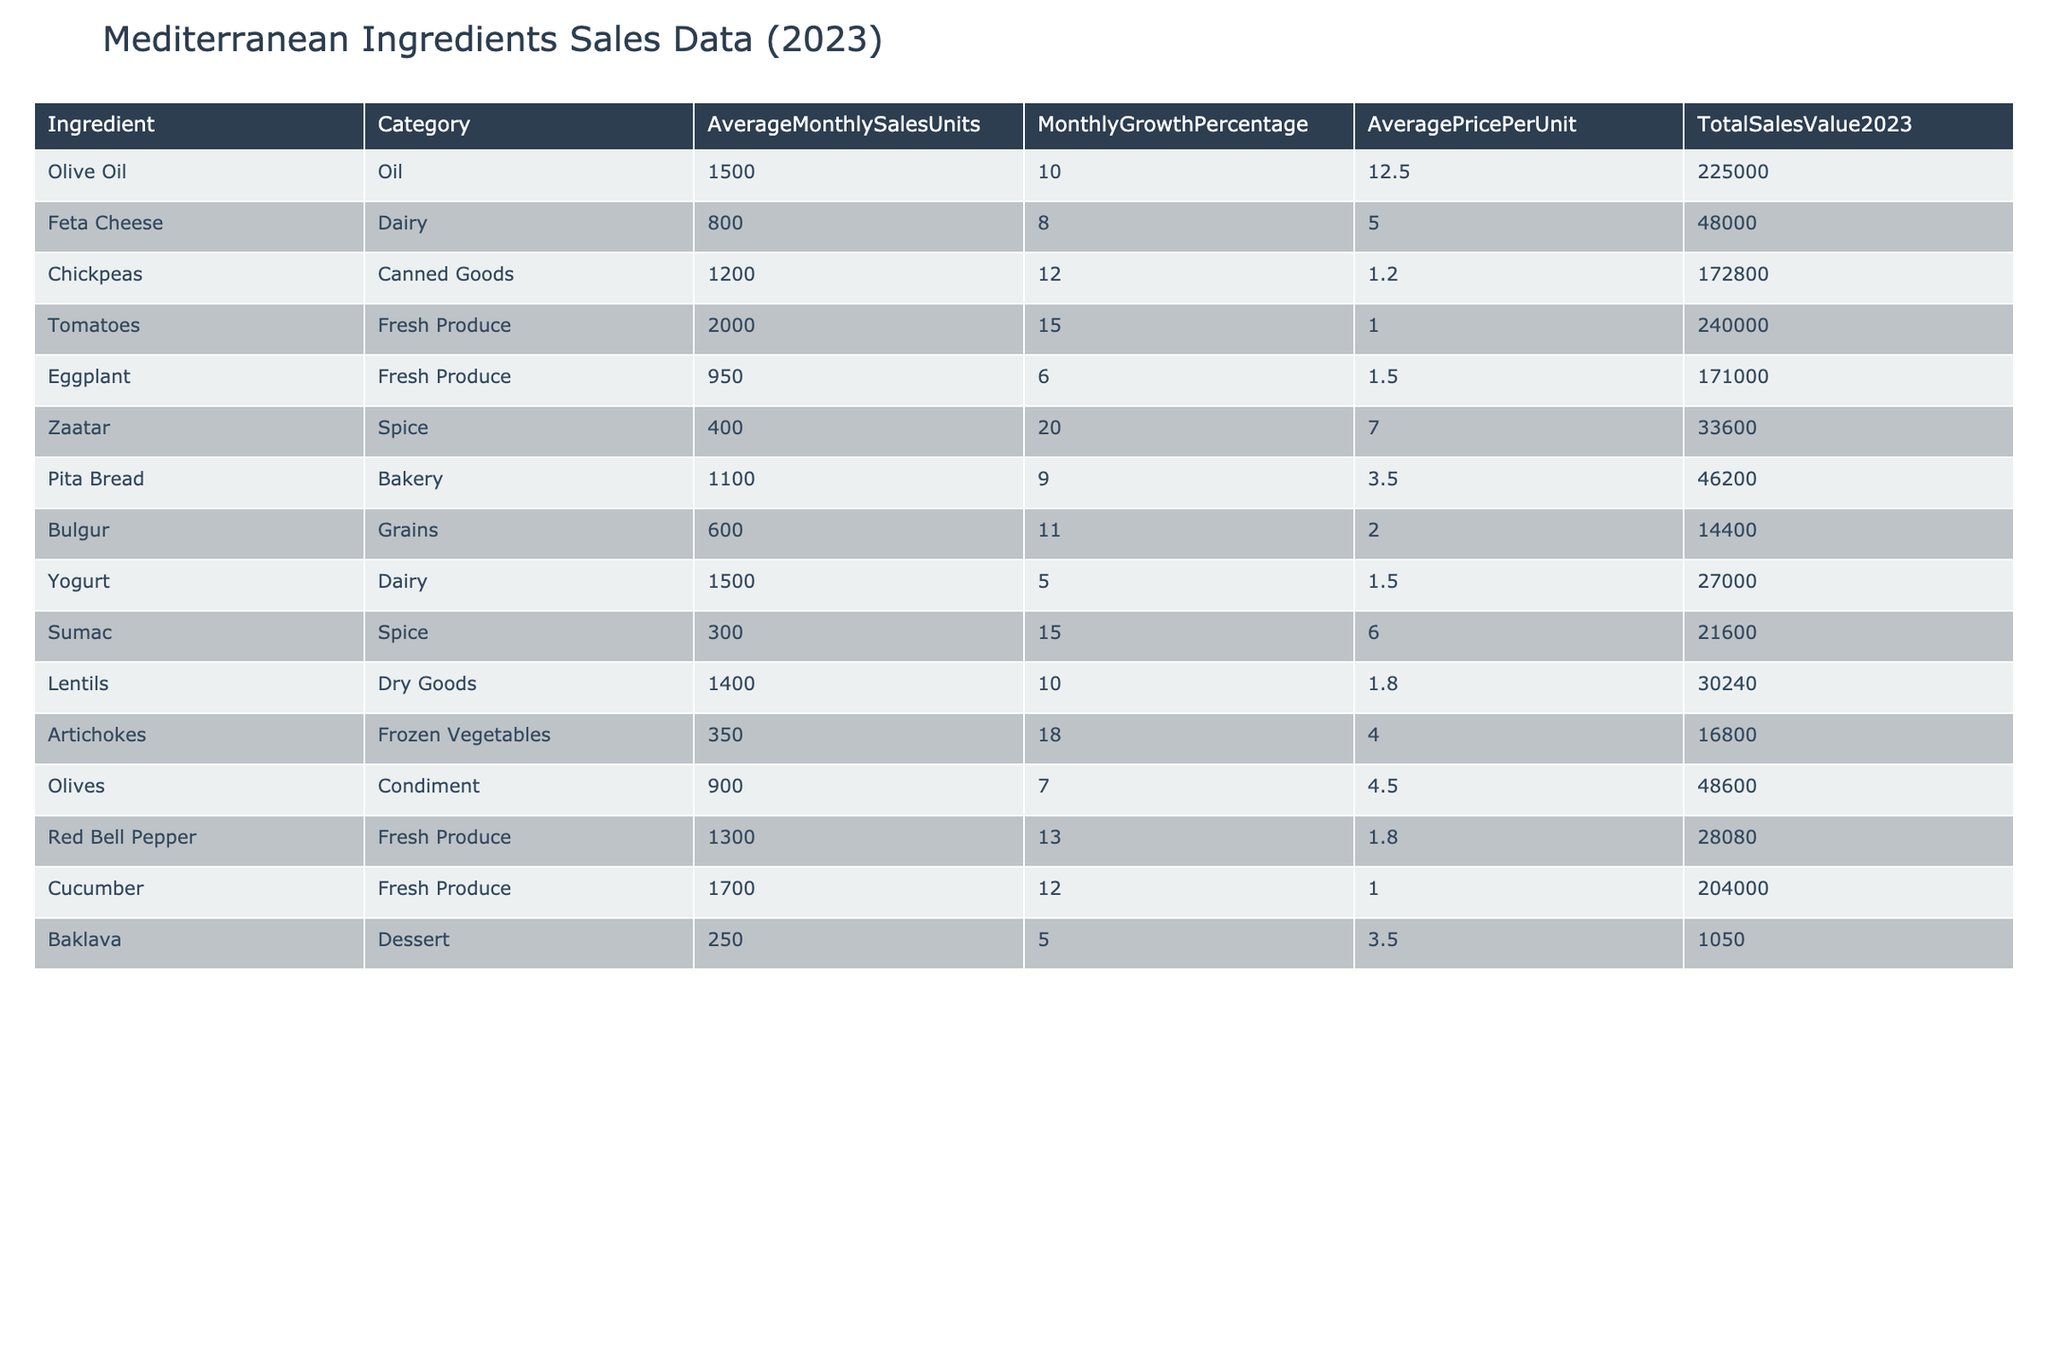What ingredient has the highest total sales value in 2023? By reviewing the "TotalSalesValue2023" column, the ingredient with the highest value is Olive Oil, which has a total sales value of 225,000.
Answer: Olive Oil What is the average price per unit for Feta Cheese? The table shows that the AveragePricePerUnit for Feta Cheese is listed as 5.00.
Answer: 5.00 Which ingredient experienced the highest monthly growth percentage? Looking at the "MonthlyGrowthPercentage" column, Zaatar has the highest growth percentage at 20%.
Answer: Zaatar Calculate the total sales value of Fresh Produce ingredients. The relevant ingredients are Tomatoes (240,000), Eggplant (171,000), Red Bell Pepper (28,080), and Cucumber (204,000). Adding these gives: 240,000 + 171,000 + 28,080 + 204,000 = 643,080.
Answer: 643,080 Is the average monthly sales unit for Olive Oil greater than 1,500? The table indicates that average monthly sales for Olive Oil is exactly 1,500, hence it is not greater.
Answer: No What are the average monthly sales units of Dairy products combined? The Dairy products are Feta Cheese (800) and Yogurt (1,500). Adding these together gives: 800 + 1500 = 2,300.
Answer: 2,300 Which category has the ingredient with the lowest total sales value? The lowest total sales value is for Baklava in the Dessert category, which sums up to only 1,050.
Answer: Dessert Calculate the growth differential between Chickpeas and Yogurt. Chickpeas have a growth percentage of 12%, while Yogurt's growth percentage is 5%. The difference is calculated as 12% - 5% = 7%.
Answer: 7% How many ingredients have an average price per unit higher than 5.00? The ingredients with prices above 5.00 are Olive Oil (12.50), Zaatar (7.00), and Sumac (6.00), totaling 3 ingredients.
Answer: 3 What is the total sales value for the Grains category? The only ingredient listed under Grains is Bulgur, which has a total sales value of 14,400.
Answer: 14,400 